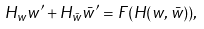Convert formula to latex. <formula><loc_0><loc_0><loc_500><loc_500>H _ { w } w ^ { \prime } + H _ { \bar { w } } { \bar { w } } ^ { \prime } = F ( H ( w , { \bar { w } } ) ) ,</formula> 